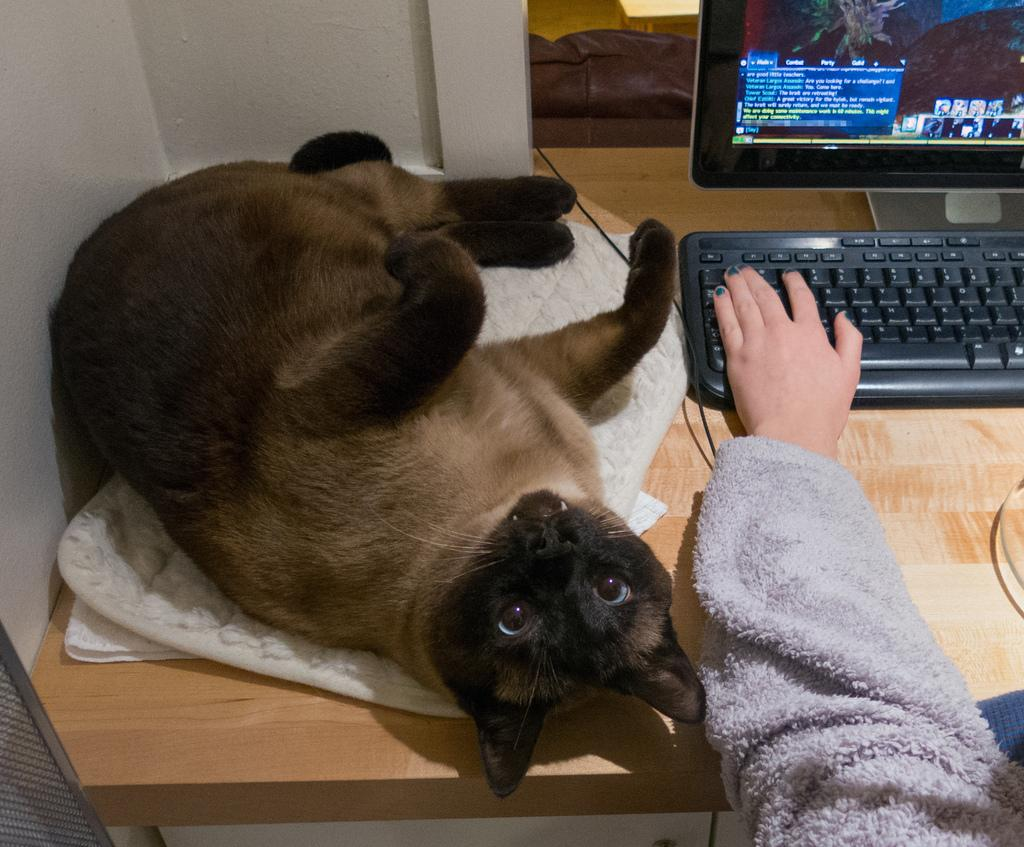What type of animal is in the image? There is a cat in the image. What color is the cat? The cat is brown in color. Where is the cat located in the image? The cat is on a table. What color is the table? The table is brown in color. Can you describe any other objects or body parts visible in the image? There is a person's hand visible in the image, and there is a system (possibly a computer or electronic device) on the table. What type of thread is being used to sew the cat's condition in the image? There is no thread or sewing activity present in the image. The cat is simply sitting on a table. --- Facts: 1. There is a person holding a book in the image. 2. The book has a blue cover. 3. The person is sitting on a chair. 4. There is a desk in the image. 5. The desk has a lamp on it. Absurd Topics: dance, ocean, parrot Conversation: What is the person in the image holding? The person is holding a book in the image. What color is the book's cover? The book has a blue cover. Where is the person sitting? The person is sitting on a chair. What other furniture or objects can be seen in the image? There is a desk in the image, and a lamp is on the desk. Reasoning: Let's think step by step in order to produce the conversation. We start by identifying the main subject in the image, which is the person holding a book. Then, we expand the conversation to include other details about the book, such as its color. Next, we describe the person's location and posture, mentioning that they are sitting on a chair. Finally, we mention the presence of a desk and a lamp, which adds context to the scene. Absurd Question/Answer: Can you see any parrots dancing in the ocean in the image? No, there are no parrots or ocean visible in the image. The image features a person holding a book and sitting on a chair, with a desk and lamp nearby. 